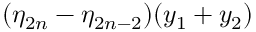Convert formula to latex. <formula><loc_0><loc_0><loc_500><loc_500>( \eta _ { 2 n } - \eta _ { 2 n - 2 } ) ( y _ { 1 } + y _ { 2 } )</formula> 